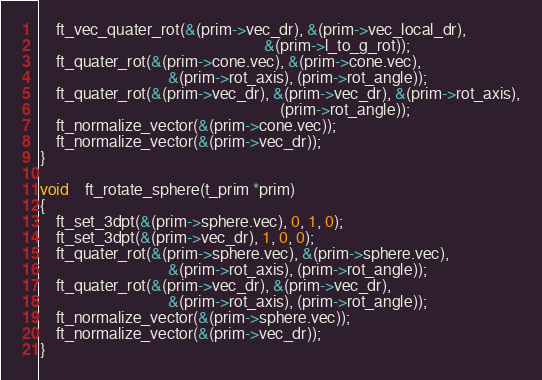<code> <loc_0><loc_0><loc_500><loc_500><_C_>	ft_vec_quater_rot(&(prim->vec_dr), &(prim->vec_local_dr),
														&(prim->l_to_g_rot));
	ft_quater_rot(&(prim->cone.vec), &(prim->cone.vec),
								&(prim->rot_axis), (prim->rot_angle));
	ft_quater_rot(&(prim->vec_dr), &(prim->vec_dr), &(prim->rot_axis),
															(prim->rot_angle));
	ft_normalize_vector(&(prim->cone.vec));
	ft_normalize_vector(&(prim->vec_dr));
}

void	ft_rotate_sphere(t_prim *prim)
{
	ft_set_3dpt(&(prim->sphere.vec), 0, 1, 0);
	ft_set_3dpt(&(prim->vec_dr), 1, 0, 0);
	ft_quater_rot(&(prim->sphere.vec), &(prim->sphere.vec),
								&(prim->rot_axis), (prim->rot_angle));
	ft_quater_rot(&(prim->vec_dr), &(prim->vec_dr),
								&(prim->rot_axis), (prim->rot_angle));
	ft_normalize_vector(&(prim->sphere.vec));
	ft_normalize_vector(&(prim->vec_dr));
}
</code> 